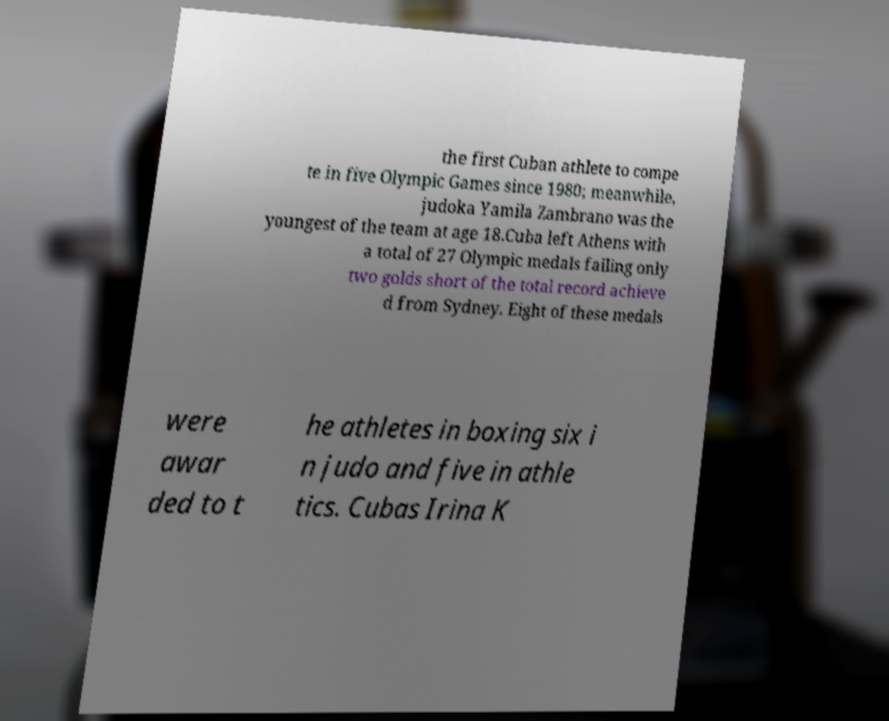Could you extract and type out the text from this image? the first Cuban athlete to compe te in five Olympic Games since 1980; meanwhile, judoka Yamila Zambrano was the youngest of the team at age 18.Cuba left Athens with a total of 27 Olympic medals failing only two golds short of the total record achieve d from Sydney. Eight of these medals were awar ded to t he athletes in boxing six i n judo and five in athle tics. Cubas Irina K 